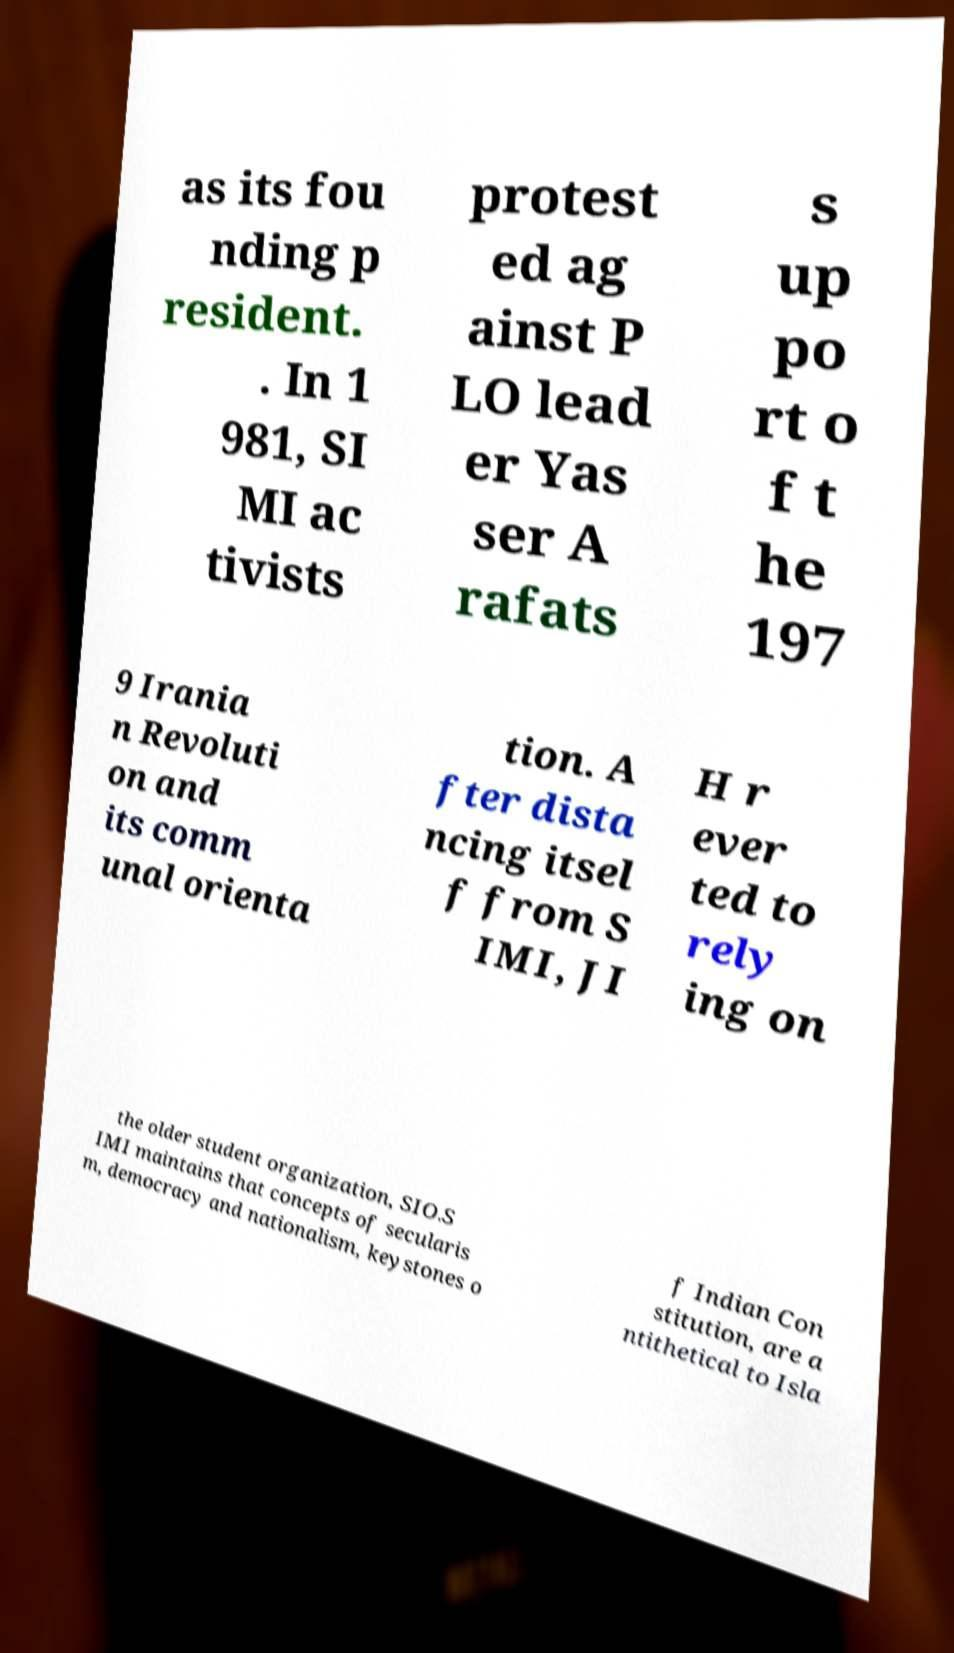Can you accurately transcribe the text from the provided image for me? as its fou nding p resident. . In 1 981, SI MI ac tivists protest ed ag ainst P LO lead er Yas ser A rafats s up po rt o f t he 197 9 Irania n Revoluti on and its comm unal orienta tion. A fter dista ncing itsel f from S IMI, JI H r ever ted to rely ing on the older student organization, SIO.S IMI maintains that concepts of secularis m, democracy and nationalism, keystones o f Indian Con stitution, are a ntithetical to Isla 